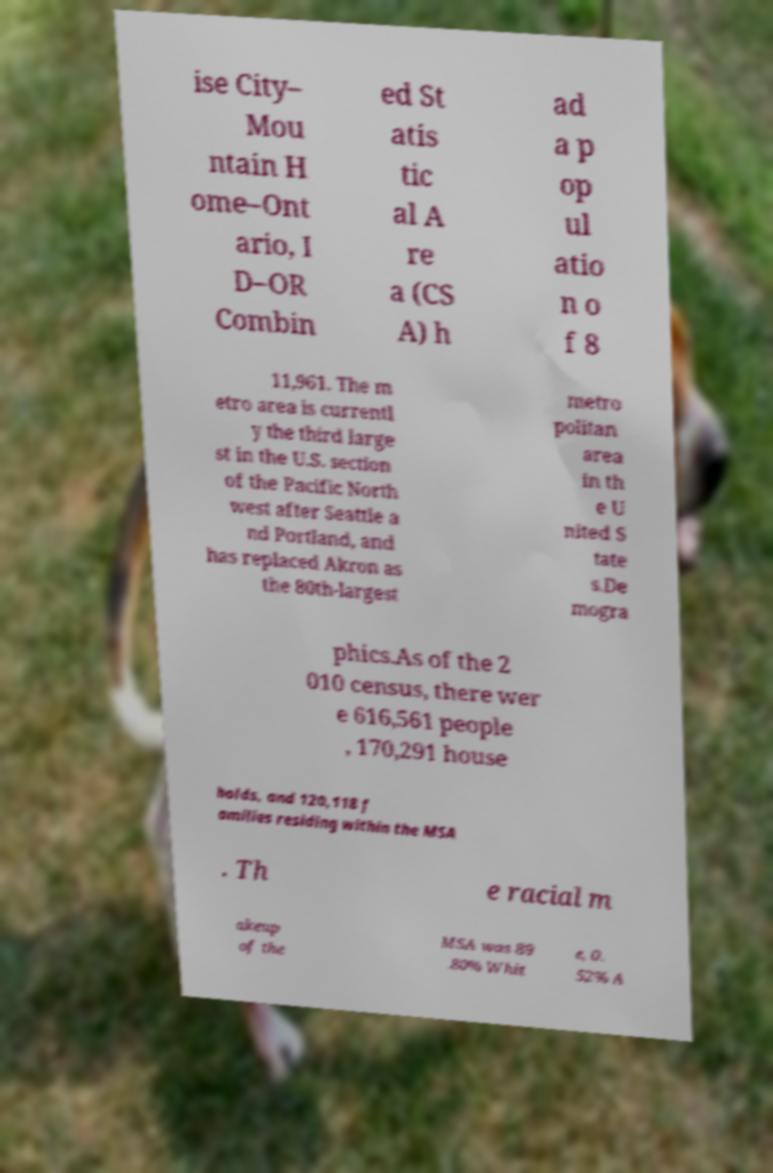Please identify and transcribe the text found in this image. ise City– Mou ntain H ome–Ont ario, I D–OR Combin ed St atis tic al A re a (CS A) h ad a p op ul atio n o f 8 11,961. The m etro area is currentl y the third large st in the U.S. section of the Pacific North west after Seattle a nd Portland, and has replaced Akron as the 80th-largest metro politan area in th e U nited S tate s.De mogra phics.As of the 2 010 census, there wer e 616,561 people , 170,291 house holds, and 120,118 f amilies residing within the MSA . Th e racial m akeup of the MSA was 89 .80% Whit e, 0. 52% A 